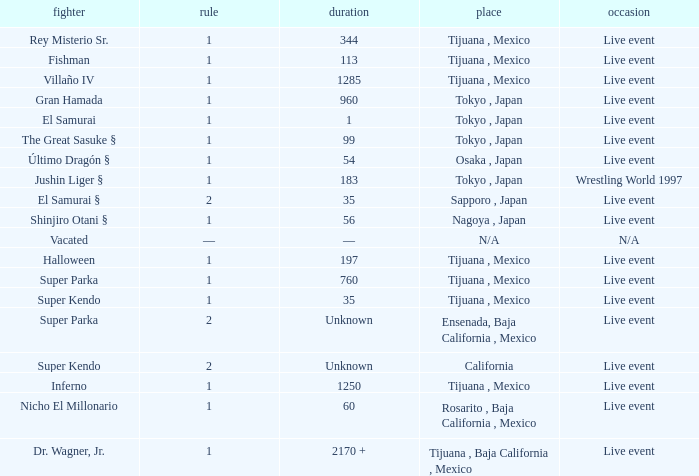What type of event had the wrestler with a reign of 2 and held the title for 35 days? Live event. 